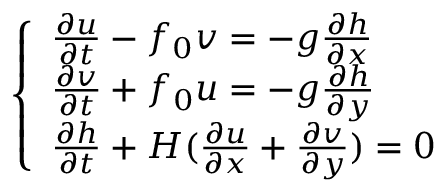<formula> <loc_0><loc_0><loc_500><loc_500>\left \{ \begin{array} { l l } { \frac { \partial u } { \partial t } - f _ { 0 } v = - g \frac { \partial h } { \partial x } } \\ { \frac { \partial v } { \partial t } + f _ { 0 } u = - g \frac { \partial h } { \partial y } } \\ { \frac { \partial h } { \partial t } + H ( \frac { \partial u } { \partial x } + \frac { \partial v } { \partial y } ) = 0 } \end{array}</formula> 